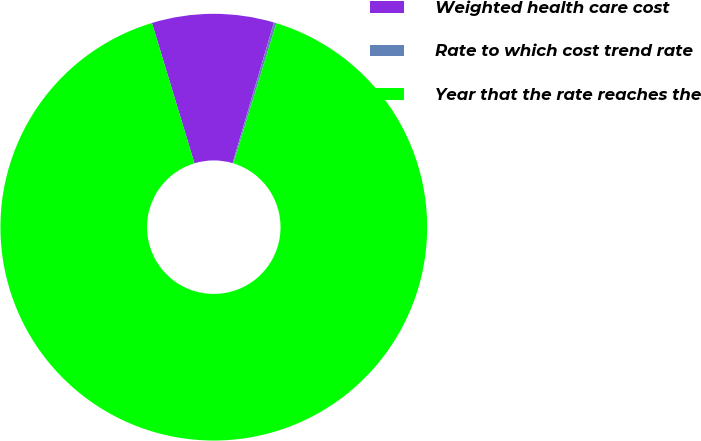<chart> <loc_0><loc_0><loc_500><loc_500><pie_chart><fcel>Weighted health care cost<fcel>Rate to which cost trend rate<fcel>Year that the rate reaches the<nl><fcel>9.23%<fcel>0.19%<fcel>90.57%<nl></chart> 